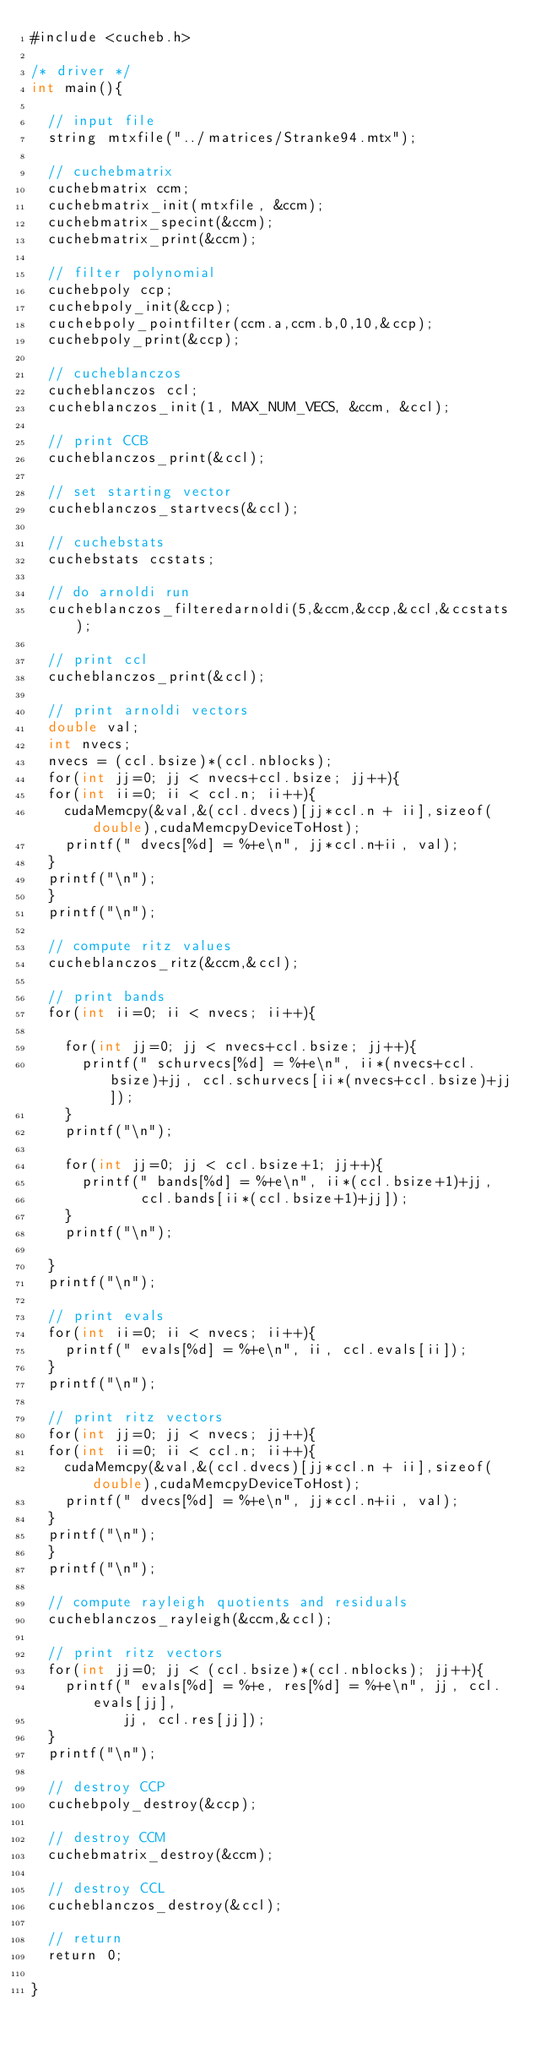Convert code to text. <code><loc_0><loc_0><loc_500><loc_500><_Cuda_>#include <cucheb.h>

/* driver */
int main(){

  // input file
  string mtxfile("../matrices/Stranke94.mtx");

  // cuchebmatrix
  cuchebmatrix ccm;
  cuchebmatrix_init(mtxfile, &ccm);
  cuchebmatrix_specint(&ccm);
  cuchebmatrix_print(&ccm);

  // filter polynomial
  cuchebpoly ccp;
  cuchebpoly_init(&ccp);
  cuchebpoly_pointfilter(ccm.a,ccm.b,0,10,&ccp);
  cuchebpoly_print(&ccp);

  // cucheblanczos
  cucheblanczos ccl;
  cucheblanczos_init(1, MAX_NUM_VECS, &ccm, &ccl);

  // print CCB
  cucheblanczos_print(&ccl);

  // set starting vector
  cucheblanczos_startvecs(&ccl);

  // cuchebstats
  cuchebstats ccstats;

  // do arnoldi run
  cucheblanczos_filteredarnoldi(5,&ccm,&ccp,&ccl,&ccstats);

  // print ccl
  cucheblanczos_print(&ccl);

  // print arnoldi vectors
  double val;
  int nvecs;
  nvecs = (ccl.bsize)*(ccl.nblocks);
  for(int jj=0; jj < nvecs+ccl.bsize; jj++){
  for(int ii=0; ii < ccl.n; ii++){
    cudaMemcpy(&val,&(ccl.dvecs)[jj*ccl.n + ii],sizeof(double),cudaMemcpyDeviceToHost);
    printf(" dvecs[%d] = %+e\n", jj*ccl.n+ii, val);
  }
  printf("\n");
  }
  printf("\n");

  // compute ritz values
  cucheblanczos_ritz(&ccm,&ccl);

  // print bands
  for(int ii=0; ii < nvecs; ii++){

    for(int jj=0; jj < nvecs+ccl.bsize; jj++){
      printf(" schurvecs[%d] = %+e\n", ii*(nvecs+ccl.bsize)+jj, ccl.schurvecs[ii*(nvecs+ccl.bsize)+jj]);
    }
    printf("\n");

    for(int jj=0; jj < ccl.bsize+1; jj++){
      printf(" bands[%d] = %+e\n", ii*(ccl.bsize+1)+jj,
             ccl.bands[ii*(ccl.bsize+1)+jj]);
    }
    printf("\n");

  }
  printf("\n");

  // print evals
  for(int ii=0; ii < nvecs; ii++){
    printf(" evals[%d] = %+e\n", ii, ccl.evals[ii]);
  }
  printf("\n");

  // print ritz vectors
  for(int jj=0; jj < nvecs; jj++){
  for(int ii=0; ii < ccl.n; ii++){
    cudaMemcpy(&val,&(ccl.dvecs)[jj*ccl.n + ii],sizeof(double),cudaMemcpyDeviceToHost);
    printf(" dvecs[%d] = %+e\n", jj*ccl.n+ii, val);
  }
  printf("\n");
  }
  printf("\n");

  // compute rayleigh quotients and residuals
  cucheblanczos_rayleigh(&ccm,&ccl);

  // print ritz vectors
  for(int jj=0; jj < (ccl.bsize)*(ccl.nblocks); jj++){
    printf(" evals[%d] = %+e, res[%d] = %+e\n", jj, ccl.evals[jj], 
           jj, ccl.res[jj]);
  }
  printf("\n");

  // destroy CCP
  cuchebpoly_destroy(&ccp);

  // destroy CCM
  cuchebmatrix_destroy(&ccm);

  // destroy CCL
  cucheblanczos_destroy(&ccl);

  // return 
  return 0;

}
</code> 